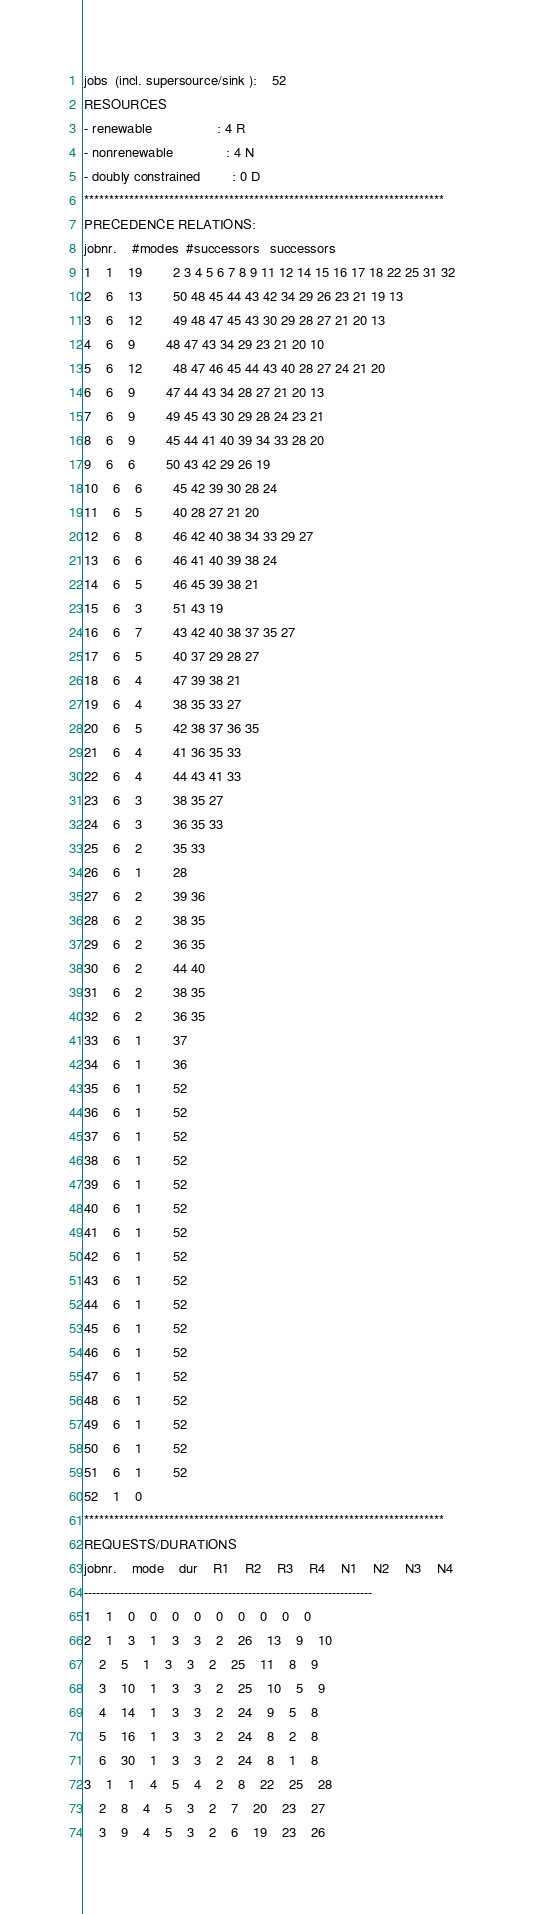Convert code to text. <code><loc_0><loc_0><loc_500><loc_500><_ObjectiveC_>jobs  (incl. supersource/sink ):	52
RESOURCES
- renewable                 : 4 R
- nonrenewable              : 4 N
- doubly constrained        : 0 D
************************************************************************
PRECEDENCE RELATIONS:
jobnr.    #modes  #successors   successors
1	1	19		2 3 4 5 6 7 8 9 11 12 14 15 16 17 18 22 25 31 32 
2	6	13		50 48 45 44 43 42 34 29 26 23 21 19 13 
3	6	12		49 48 47 45 43 30 29 28 27 21 20 13 
4	6	9		48 47 43 34 29 23 21 20 10 
5	6	12		48 47 46 45 44 43 40 28 27 24 21 20 
6	6	9		47 44 43 34 28 27 21 20 13 
7	6	9		49 45 43 30 29 28 24 23 21 
8	6	9		45 44 41 40 39 34 33 28 20 
9	6	6		50 43 42 29 26 19 
10	6	6		45 42 39 30 28 24 
11	6	5		40 28 27 21 20 
12	6	8		46 42 40 38 34 33 29 27 
13	6	6		46 41 40 39 38 24 
14	6	5		46 45 39 38 21 
15	6	3		51 43 19 
16	6	7		43 42 40 38 37 35 27 
17	6	5		40 37 29 28 27 
18	6	4		47 39 38 21 
19	6	4		38 35 33 27 
20	6	5		42 38 37 36 35 
21	6	4		41 36 35 33 
22	6	4		44 43 41 33 
23	6	3		38 35 27 
24	6	3		36 35 33 
25	6	2		35 33 
26	6	1		28 
27	6	2		39 36 
28	6	2		38 35 
29	6	2		36 35 
30	6	2		44 40 
31	6	2		38 35 
32	6	2		36 35 
33	6	1		37 
34	6	1		36 
35	6	1		52 
36	6	1		52 
37	6	1		52 
38	6	1		52 
39	6	1		52 
40	6	1		52 
41	6	1		52 
42	6	1		52 
43	6	1		52 
44	6	1		52 
45	6	1		52 
46	6	1		52 
47	6	1		52 
48	6	1		52 
49	6	1		52 
50	6	1		52 
51	6	1		52 
52	1	0		
************************************************************************
REQUESTS/DURATIONS
jobnr.	mode	dur	R1	R2	R3	R4	N1	N2	N3	N4	
------------------------------------------------------------------------
1	1	0	0	0	0	0	0	0	0	0	
2	1	3	1	3	3	2	26	13	9	10	
	2	5	1	3	3	2	25	11	8	9	
	3	10	1	3	3	2	25	10	5	9	
	4	14	1	3	3	2	24	9	5	8	
	5	16	1	3	3	2	24	8	2	8	
	6	30	1	3	3	2	24	8	1	8	
3	1	1	4	5	4	2	8	22	25	28	
	2	8	4	5	3	2	7	20	23	27	
	3	9	4	5	3	2	6	19	23	26	</code> 